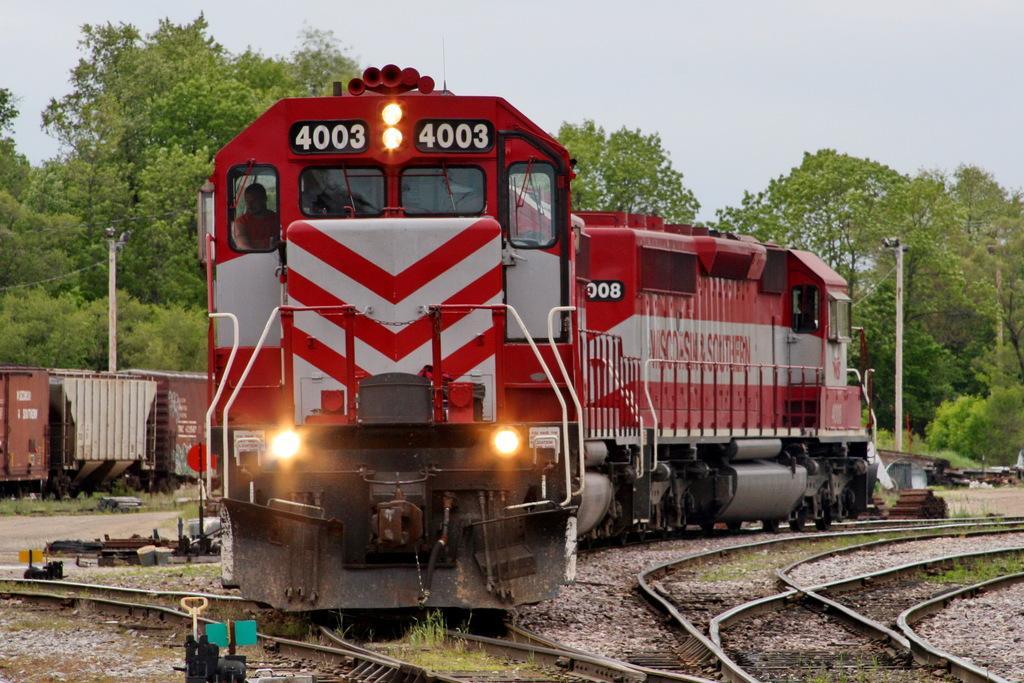Please provide a concise description of this image. In the center of the image there is a train. At the bottom of the image there are railway tracks. In the background of the image there are trees. At the top of the image there is sky. There are electric poles. 